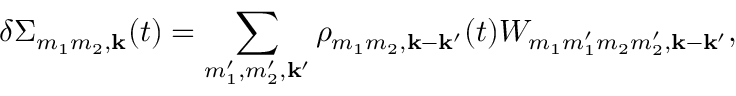Convert formula to latex. <formula><loc_0><loc_0><loc_500><loc_500>\delta \Sigma _ { m _ { 1 } m _ { 2 } , \mathbf k } ( t ) = \sum _ { m _ { 1 } ^ { \prime } , m _ { 2 } ^ { \prime } , k ^ { \prime } } \rho _ { m _ { 1 } m _ { 2 } , k - k ^ { \prime } } ( t ) W _ { m _ { 1 } m _ { 1 } ^ { \prime } m _ { 2 } m _ { 2 } ^ { \prime } , k - k ^ { \prime } } ,</formula> 